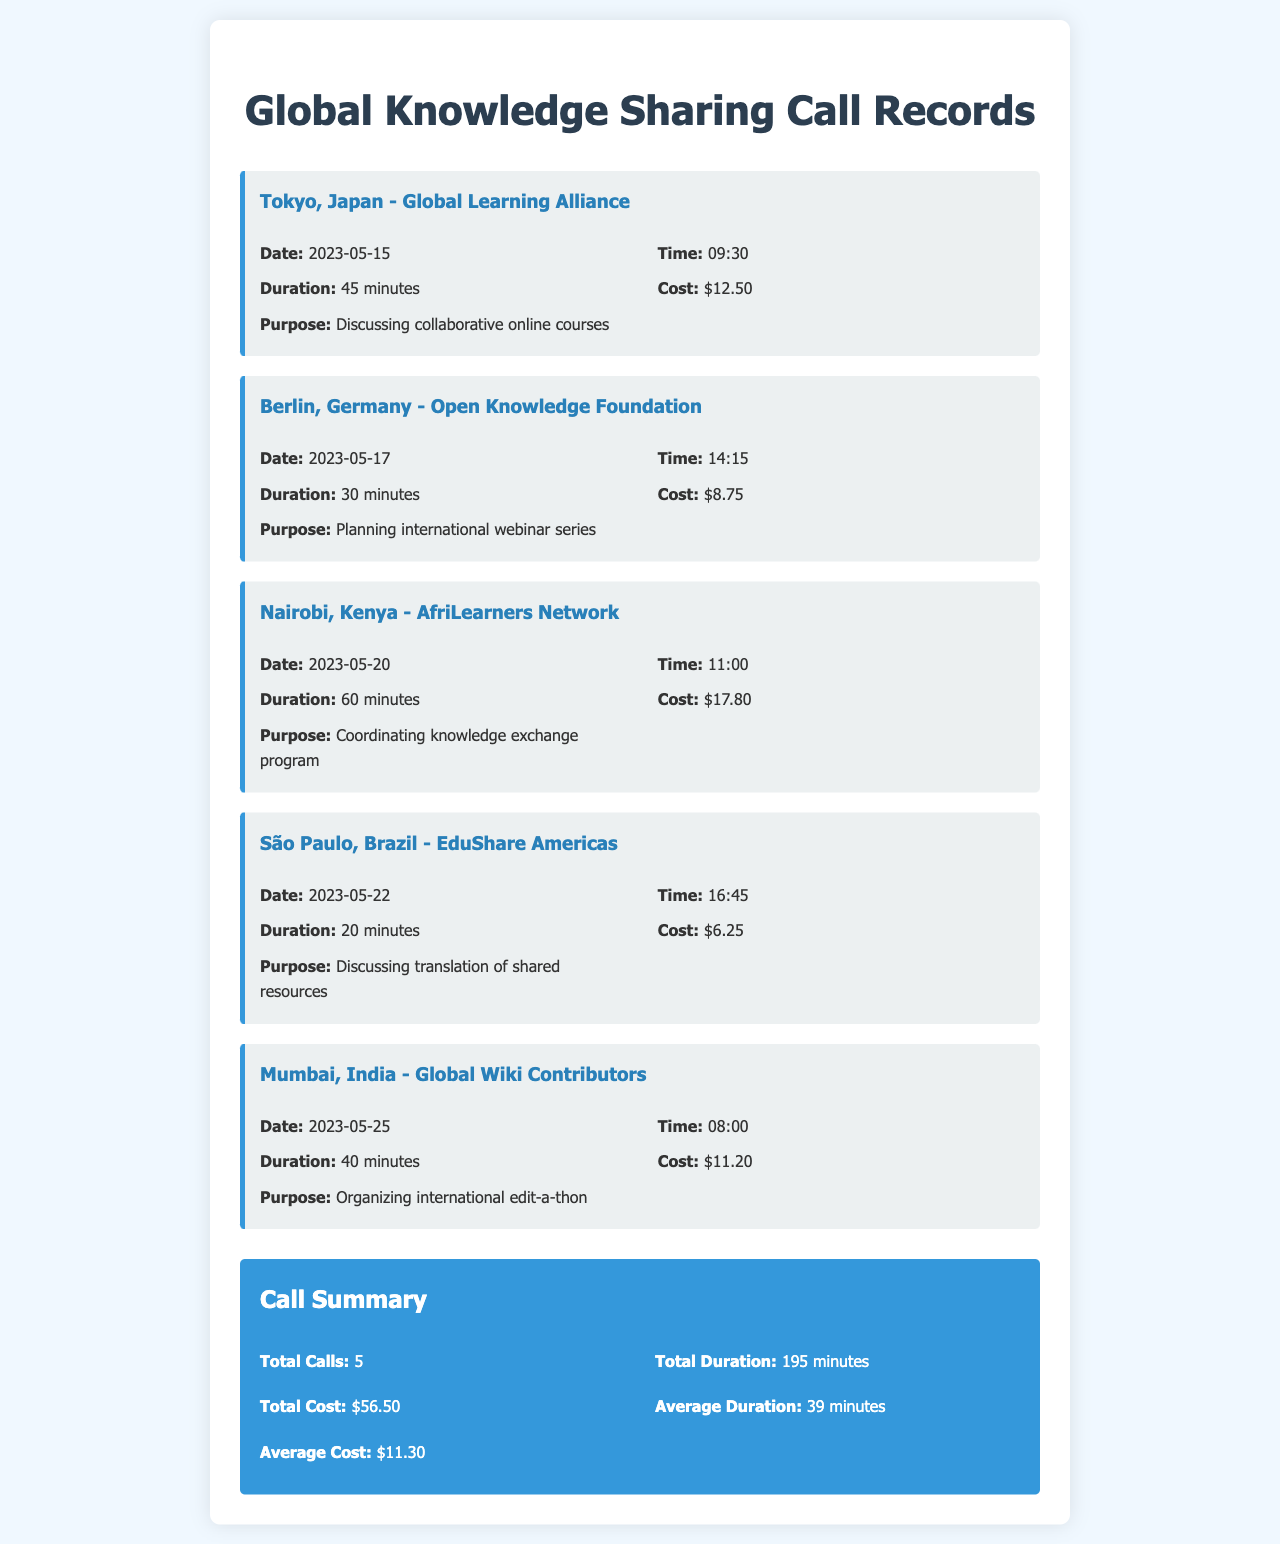What is the date of the call to Tokyo, Japan? The date of the call to Tokyo is provided in the call record section for that location.
Answer: 2023-05-15 What was the cost of the call to Berlin, Germany? The cost for the call to Berlin is mentioned in the call details for that particular call.
Answer: $8.75 What is the total duration of all calls made? The total duration of all calls is summarized at the end of the document in the summary section.
Answer: 195 minutes Which organization was contacted in Nairobi, Kenya? The organization name is specified in the header of the call record related to Nairobi.
Answer: AfriLearners Network What was the purpose of the call to São Paulo, Brazil? The purpose of the call is explicitly stated in the details of the São Paulo call record.
Answer: Discussing translation of shared resources What is the average cost of the calls made? The average cost calculation is included in the summary section of the document.
Answer: $11.30 How long was the longest call? The duration of the longest call can be inferred by comparing all the duration entries in the call records.
Answer: 60 minutes What was the time of the call to Mumbai, India? The exact time for the Mumbai call is detailed in the call record for that location.
Answer: 08:00 How many calls were made in total? The total number of calls is summarized at the end of the document.
Answer: 5 